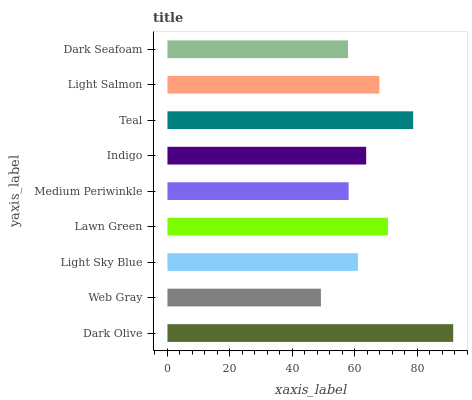Is Web Gray the minimum?
Answer yes or no. Yes. Is Dark Olive the maximum?
Answer yes or no. Yes. Is Light Sky Blue the minimum?
Answer yes or no. No. Is Light Sky Blue the maximum?
Answer yes or no. No. Is Light Sky Blue greater than Web Gray?
Answer yes or no. Yes. Is Web Gray less than Light Sky Blue?
Answer yes or no. Yes. Is Web Gray greater than Light Sky Blue?
Answer yes or no. No. Is Light Sky Blue less than Web Gray?
Answer yes or no. No. Is Indigo the high median?
Answer yes or no. Yes. Is Indigo the low median?
Answer yes or no. Yes. Is Light Sky Blue the high median?
Answer yes or no. No. Is Light Salmon the low median?
Answer yes or no. No. 